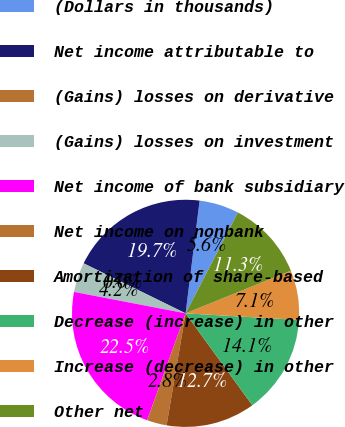Convert chart. <chart><loc_0><loc_0><loc_500><loc_500><pie_chart><fcel>(Dollars in thousands)<fcel>Net income attributable to<fcel>(Gains) losses on derivative<fcel>(Gains) losses on investment<fcel>Net income of bank subsidiary<fcel>Net income on nonbank<fcel>Amortization of share-based<fcel>Decrease (increase) in other<fcel>Increase (decrease) in other<fcel>Other net<nl><fcel>5.64%<fcel>19.71%<fcel>0.01%<fcel>4.23%<fcel>22.52%<fcel>2.82%<fcel>12.67%<fcel>14.08%<fcel>7.05%<fcel>11.27%<nl></chart> 